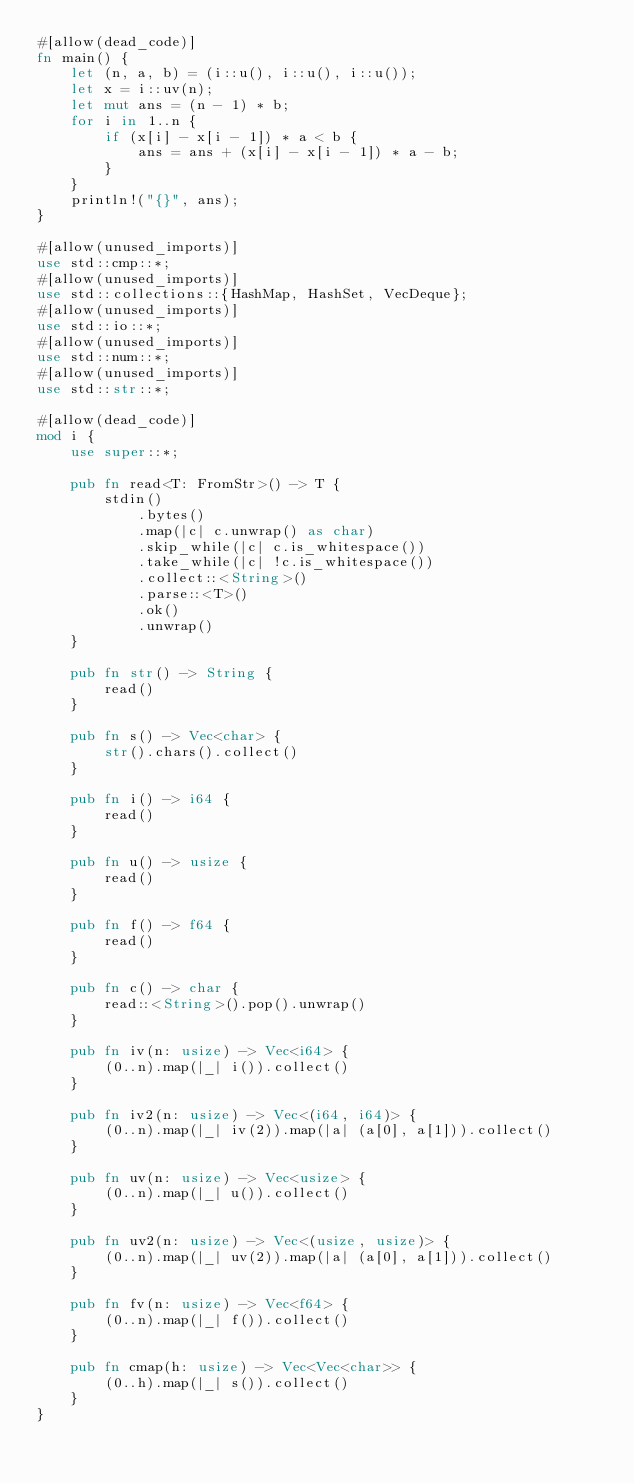<code> <loc_0><loc_0><loc_500><loc_500><_Rust_>#[allow(dead_code)]
fn main() {
    let (n, a, b) = (i::u(), i::u(), i::u());
    let x = i::uv(n);
    let mut ans = (n - 1) * b;
    for i in 1..n {
        if (x[i] - x[i - 1]) * a < b {
            ans = ans + (x[i] - x[i - 1]) * a - b;
        }
    }
    println!("{}", ans);
}

#[allow(unused_imports)]
use std::cmp::*;
#[allow(unused_imports)]
use std::collections::{HashMap, HashSet, VecDeque};
#[allow(unused_imports)]
use std::io::*;
#[allow(unused_imports)]
use std::num::*;
#[allow(unused_imports)]
use std::str::*;

#[allow(dead_code)]
mod i {
    use super::*;

    pub fn read<T: FromStr>() -> T {
        stdin()
            .bytes()
            .map(|c| c.unwrap() as char)
            .skip_while(|c| c.is_whitespace())
            .take_while(|c| !c.is_whitespace())
            .collect::<String>()
            .parse::<T>()
            .ok()
            .unwrap()
    }

    pub fn str() -> String {
        read()
    }

    pub fn s() -> Vec<char> {
        str().chars().collect()
    }

    pub fn i() -> i64 {
        read()
    }

    pub fn u() -> usize {
        read()
    }

    pub fn f() -> f64 {
        read()
    }

    pub fn c() -> char {
        read::<String>().pop().unwrap()
    }

    pub fn iv(n: usize) -> Vec<i64> {
        (0..n).map(|_| i()).collect()
    }

    pub fn iv2(n: usize) -> Vec<(i64, i64)> {
        (0..n).map(|_| iv(2)).map(|a| (a[0], a[1])).collect()
    }

    pub fn uv(n: usize) -> Vec<usize> {
        (0..n).map(|_| u()).collect()
    }

    pub fn uv2(n: usize) -> Vec<(usize, usize)> {
        (0..n).map(|_| uv(2)).map(|a| (a[0], a[1])).collect()
    }

    pub fn fv(n: usize) -> Vec<f64> {
        (0..n).map(|_| f()).collect()
    }

    pub fn cmap(h: usize) -> Vec<Vec<char>> {
        (0..h).map(|_| s()).collect()
    }
}
</code> 